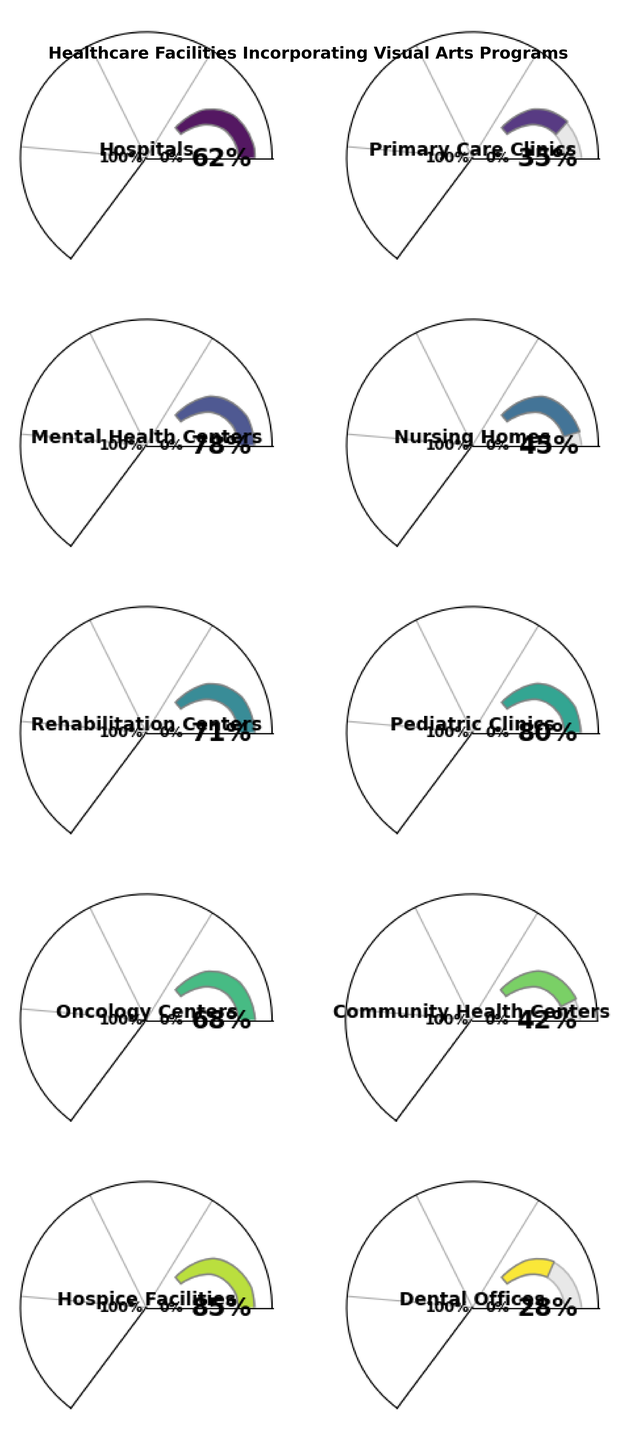Which facility has the highest percentage of visual arts programs incorporated? The Hospice Facilities gauge shows the highest percentage at 85%. Since no other gauge shows a higher value, Hospice Facilities have the highest percentage.
Answer: Hospice Facilities What is the title of the figure? The title is typically found at the top of the figure, and it provides an overview of what the figure is depicting. In this case, it reads "Healthcare Facilities Incorporating Visual Arts Programs."
Answer: Healthcare Facilities Incorporating Visual Arts Programs Which facility type has nearly half of its facilities incorporating visual arts programs? Looking at the gauges, the Nursing Homes gauge shows approximately 45%, which is nearly half of the value.
Answer: Nursing Homes How many facility types are displayed in the figure? By counting the number of gauges in the plot, we see that there are 10 facility types.
Answer: 10 What is the difference in the percentage of visual arts programs between Pediatric Clinics and Dental Offices? Pediatric Clinics show 80% while Dental Offices show 28%. The difference is calculated by subtracting 28 from 80.
Answer: 52% Which facility types have less than 40% of their facilities incorporating visual arts programs? By looking at each gauge, we observe that Primary Care Clinics (35%) and Dental Offices (28%) have less than 40% incorporation.
Answer: Primary Care Clinics, Dental Offices What is the range in percentage values represented by the various facility types in the figure? The lowest percentage is 28% (Dental Offices) and the highest is 85% (Hospice Facilities). The range is found by subtracting the lowest value from the highest value.
Answer: 57% Are there more facility types with percentages above or below 50%? By counting the gauges above 50% (Hospitals, Mental Health Centers, Rehabilitation Centers, Pediatric Clinics, Oncology Centers, Hospice Facilities) and those below 50% (Primary Care Clinics, Nursing Homes, Community Health Centers, Dental Offices), we find there are more above.
Answer: Above Which specific facility type has a percentage just above 60%? By examining the gauges, the Hospitals gauge shows a percentage of 62%, which is just above 60%.
Answer: Hospitals 